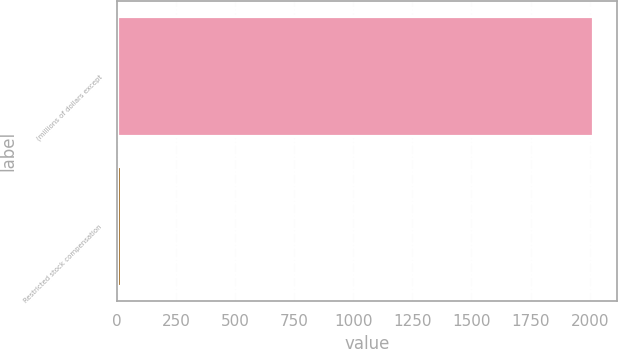Convert chart to OTSL. <chart><loc_0><loc_0><loc_500><loc_500><bar_chart><fcel>(millions of dollars except<fcel>Restricted stock compensation<nl><fcel>2016<fcel>19.5<nl></chart> 